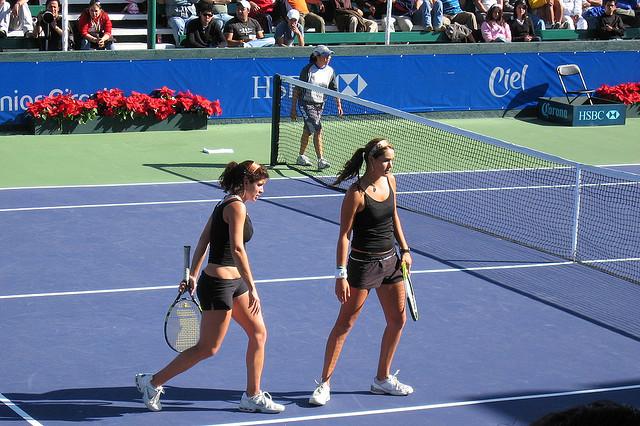Are these woman elderly?
Quick response, please. No. Are these women twins?
Be succinct. No. What sport is being played?
Write a very short answer. Tennis. 